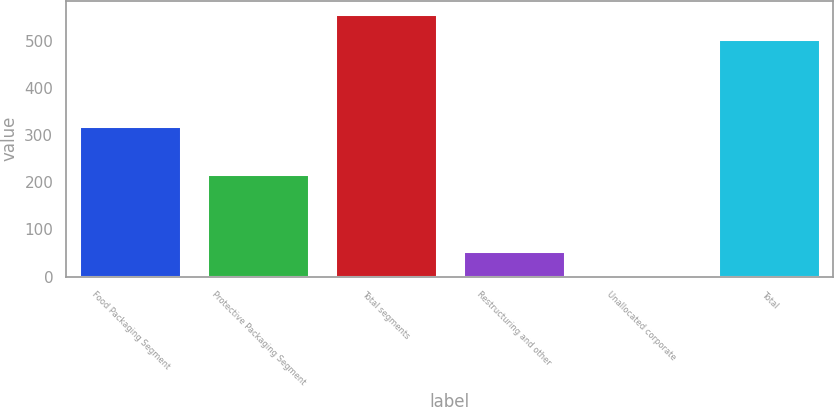<chart> <loc_0><loc_0><loc_500><loc_500><bar_chart><fcel>Food Packaging Segment<fcel>Protective Packaging Segment<fcel>Total segments<fcel>Restructuring and other<fcel>Unallocated corporate<fcel>Total<nl><fcel>319.3<fcel>217.6<fcel>556.6<fcel>54.5<fcel>0.9<fcel>503<nl></chart> 